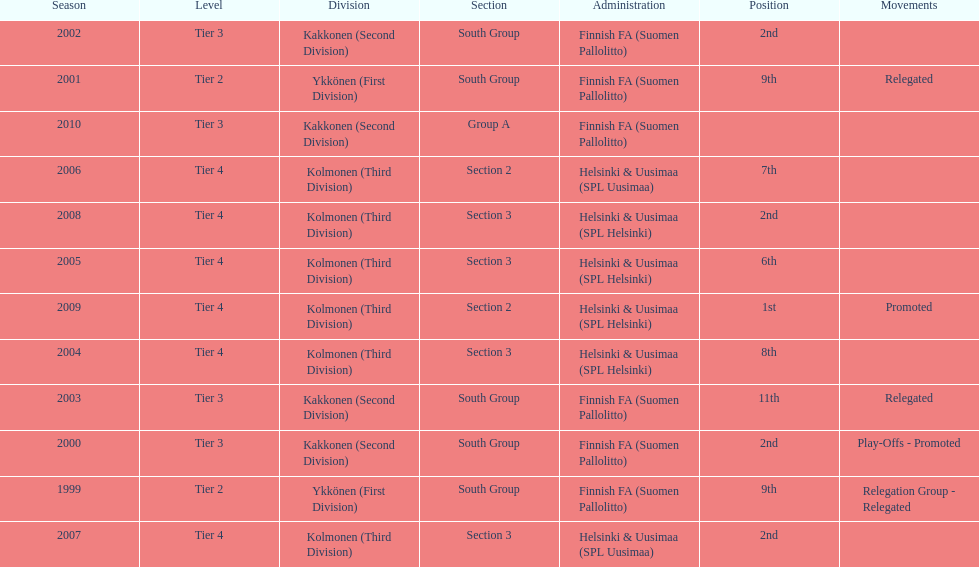Which administration has the minimal amount of separation? Helsinki & Uusimaa (SPL Helsinki). 